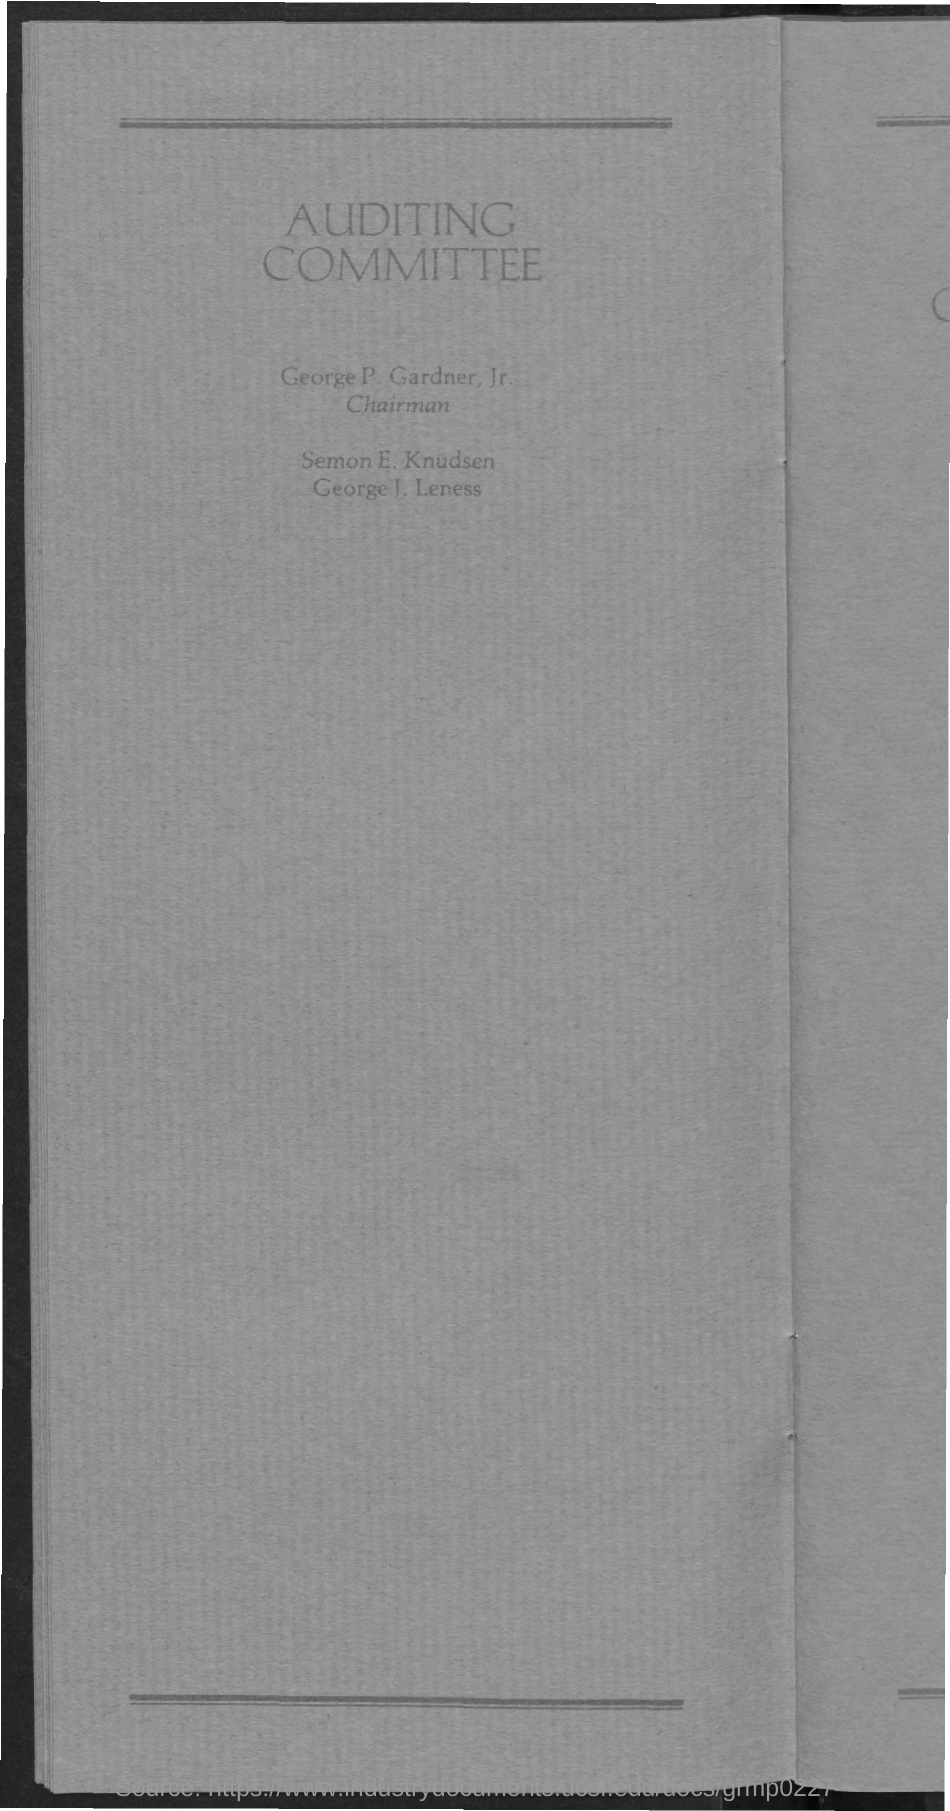What is the Title of the document?
Make the answer very short. AUDITING COMMITTEE. 